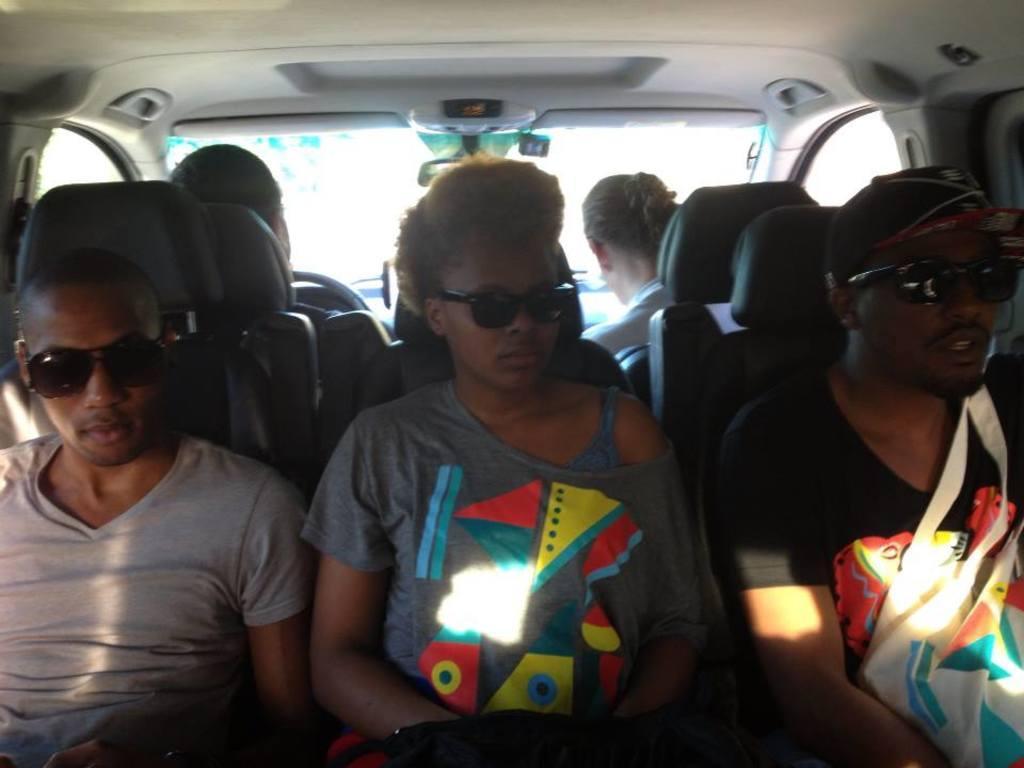In one or two sentences, can you explain what this image depicts? This image is taken from inside a vehicle as we can see there are some persons sitting on the chairs in the middle of this image , and there is a glass in the background. 